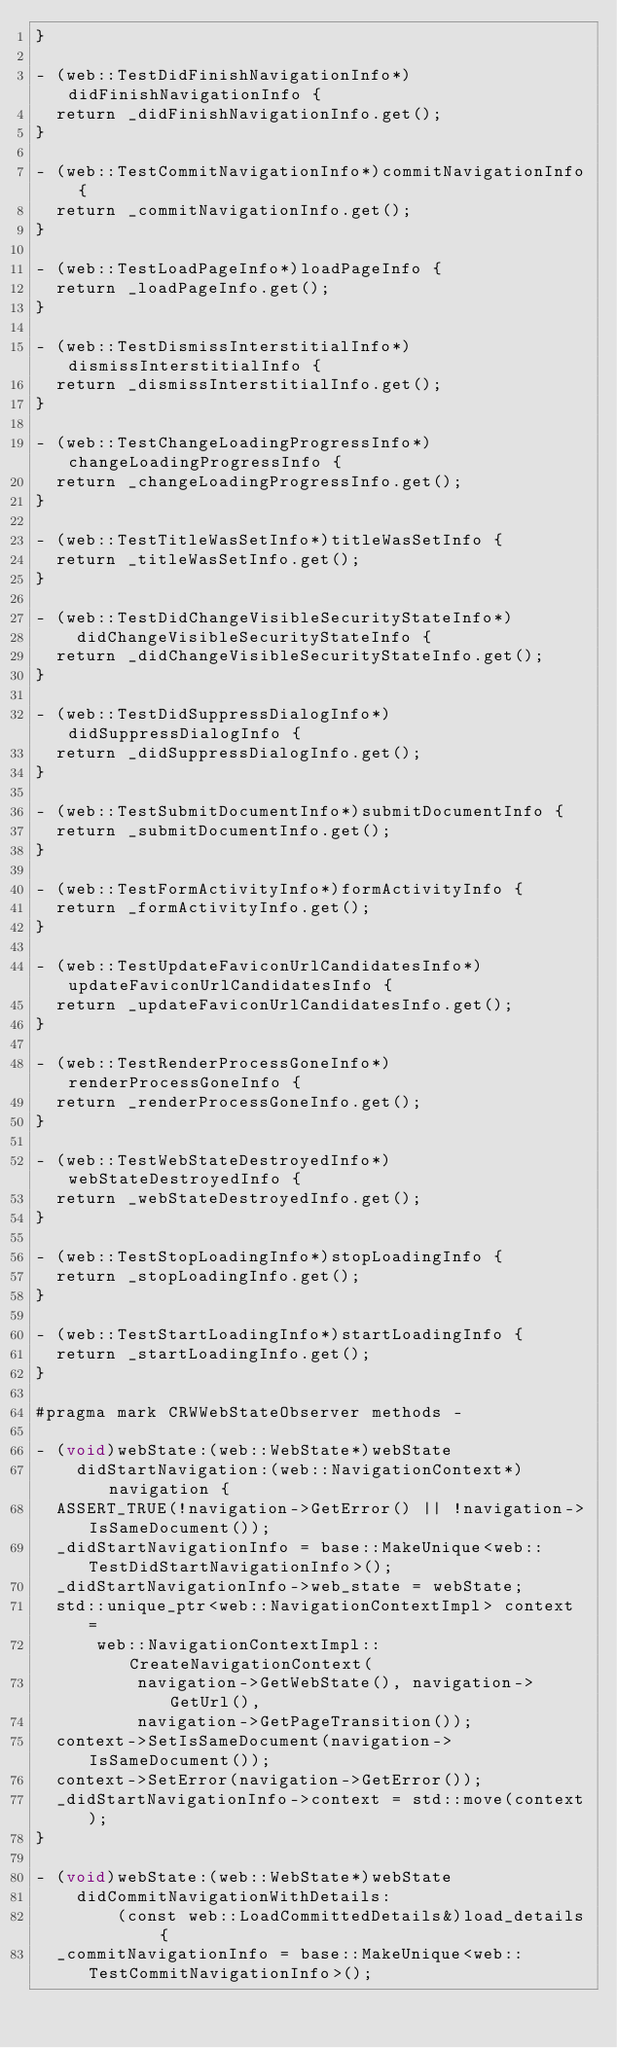<code> <loc_0><loc_0><loc_500><loc_500><_ObjectiveC_>}

- (web::TestDidFinishNavigationInfo*)didFinishNavigationInfo {
  return _didFinishNavigationInfo.get();
}

- (web::TestCommitNavigationInfo*)commitNavigationInfo {
  return _commitNavigationInfo.get();
}

- (web::TestLoadPageInfo*)loadPageInfo {
  return _loadPageInfo.get();
}

- (web::TestDismissInterstitialInfo*)dismissInterstitialInfo {
  return _dismissInterstitialInfo.get();
}

- (web::TestChangeLoadingProgressInfo*)changeLoadingProgressInfo {
  return _changeLoadingProgressInfo.get();
}

- (web::TestTitleWasSetInfo*)titleWasSetInfo {
  return _titleWasSetInfo.get();
}

- (web::TestDidChangeVisibleSecurityStateInfo*)
    didChangeVisibleSecurityStateInfo {
  return _didChangeVisibleSecurityStateInfo.get();
}

- (web::TestDidSuppressDialogInfo*)didSuppressDialogInfo {
  return _didSuppressDialogInfo.get();
}

- (web::TestSubmitDocumentInfo*)submitDocumentInfo {
  return _submitDocumentInfo.get();
}

- (web::TestFormActivityInfo*)formActivityInfo {
  return _formActivityInfo.get();
}

- (web::TestUpdateFaviconUrlCandidatesInfo*)updateFaviconUrlCandidatesInfo {
  return _updateFaviconUrlCandidatesInfo.get();
}

- (web::TestRenderProcessGoneInfo*)renderProcessGoneInfo {
  return _renderProcessGoneInfo.get();
}

- (web::TestWebStateDestroyedInfo*)webStateDestroyedInfo {
  return _webStateDestroyedInfo.get();
}

- (web::TestStopLoadingInfo*)stopLoadingInfo {
  return _stopLoadingInfo.get();
}

- (web::TestStartLoadingInfo*)startLoadingInfo {
  return _startLoadingInfo.get();
}

#pragma mark CRWWebStateObserver methods -

- (void)webState:(web::WebState*)webState
    didStartNavigation:(web::NavigationContext*)navigation {
  ASSERT_TRUE(!navigation->GetError() || !navigation->IsSameDocument());
  _didStartNavigationInfo = base::MakeUnique<web::TestDidStartNavigationInfo>();
  _didStartNavigationInfo->web_state = webState;
  std::unique_ptr<web::NavigationContextImpl> context =
      web::NavigationContextImpl::CreateNavigationContext(
          navigation->GetWebState(), navigation->GetUrl(),
          navigation->GetPageTransition());
  context->SetIsSameDocument(navigation->IsSameDocument());
  context->SetError(navigation->GetError());
  _didStartNavigationInfo->context = std::move(context);
}

- (void)webState:(web::WebState*)webState
    didCommitNavigationWithDetails:
        (const web::LoadCommittedDetails&)load_details {
  _commitNavigationInfo = base::MakeUnique<web::TestCommitNavigationInfo>();</code> 